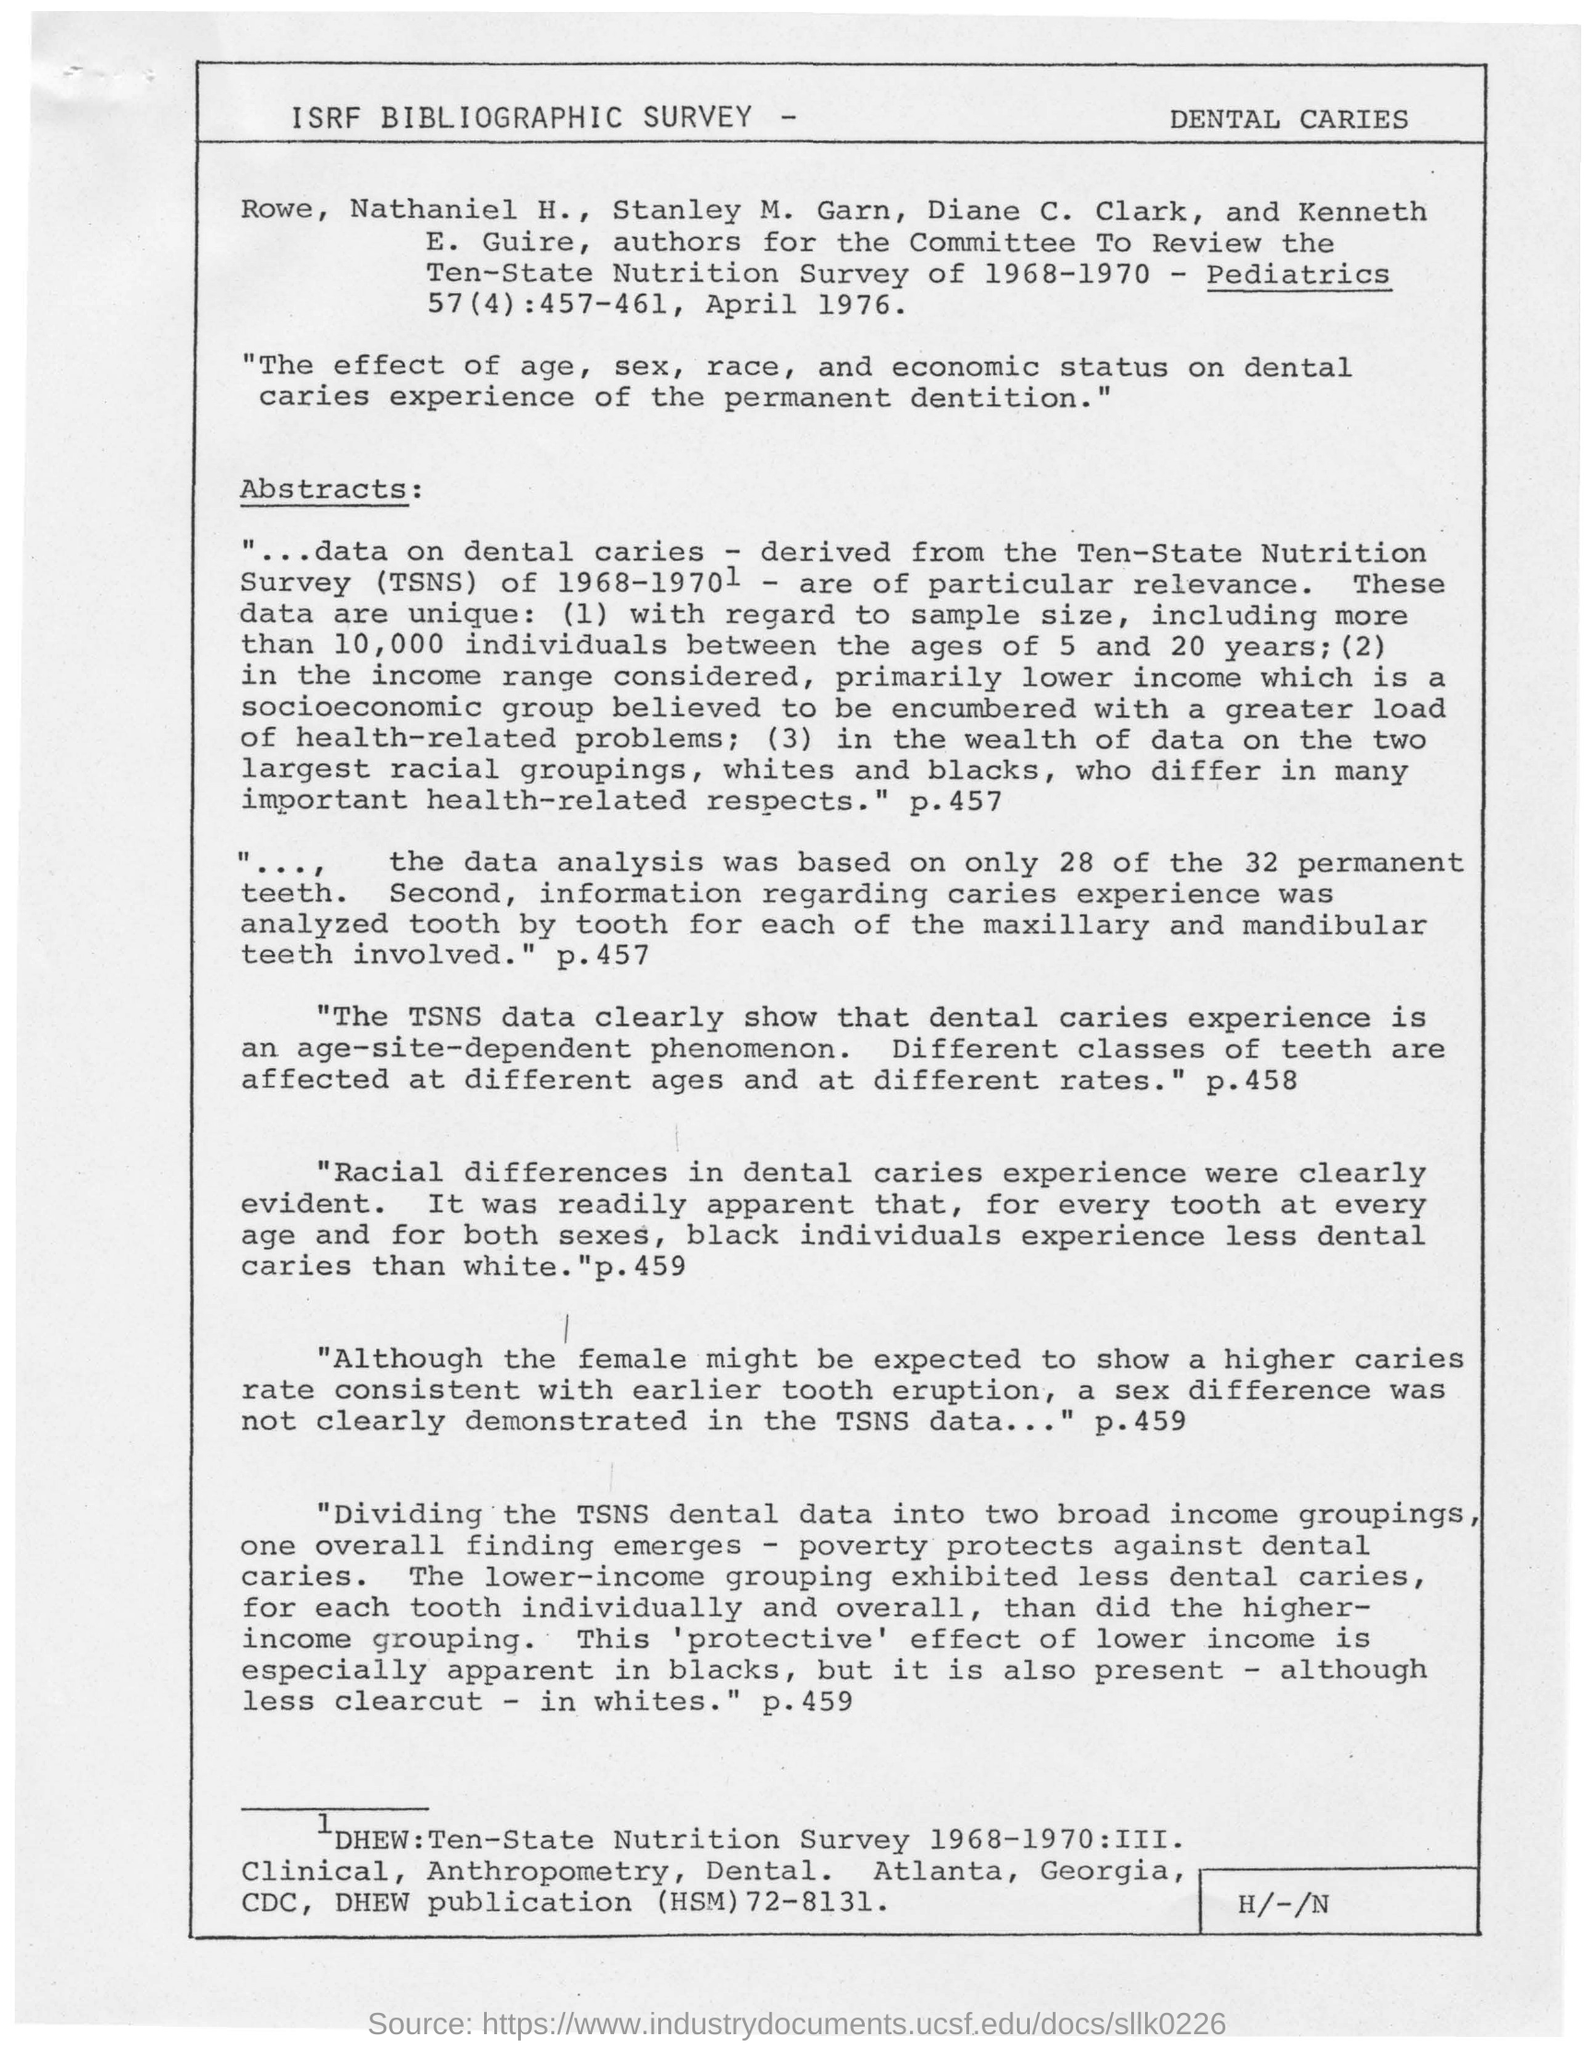What is the heading of the document?
Your answer should be very brief. ISRF BIBLIOGRAPHIC SURVEY - DENTAL CARIES. What differences in dental caries experience were clearly evident?
Offer a terse response. Racial differences. 